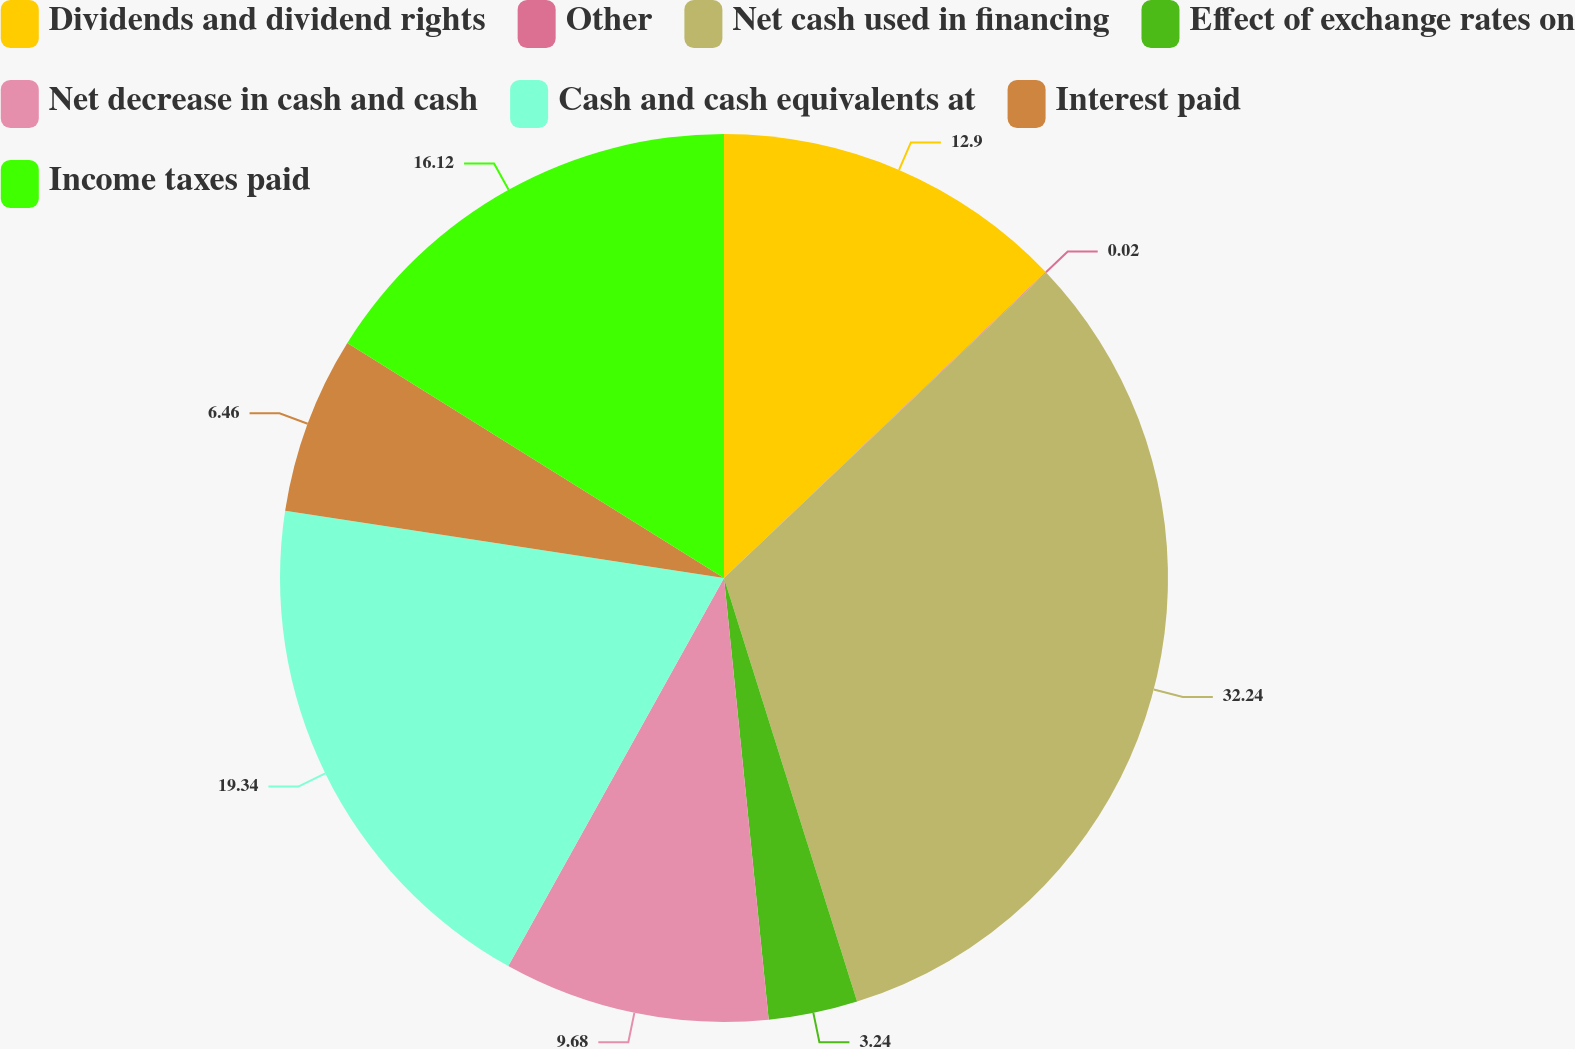Convert chart. <chart><loc_0><loc_0><loc_500><loc_500><pie_chart><fcel>Dividends and dividend rights<fcel>Other<fcel>Net cash used in financing<fcel>Effect of exchange rates on<fcel>Net decrease in cash and cash<fcel>Cash and cash equivalents at<fcel>Interest paid<fcel>Income taxes paid<nl><fcel>12.9%<fcel>0.02%<fcel>32.23%<fcel>3.24%<fcel>9.68%<fcel>19.34%<fcel>6.46%<fcel>16.12%<nl></chart> 